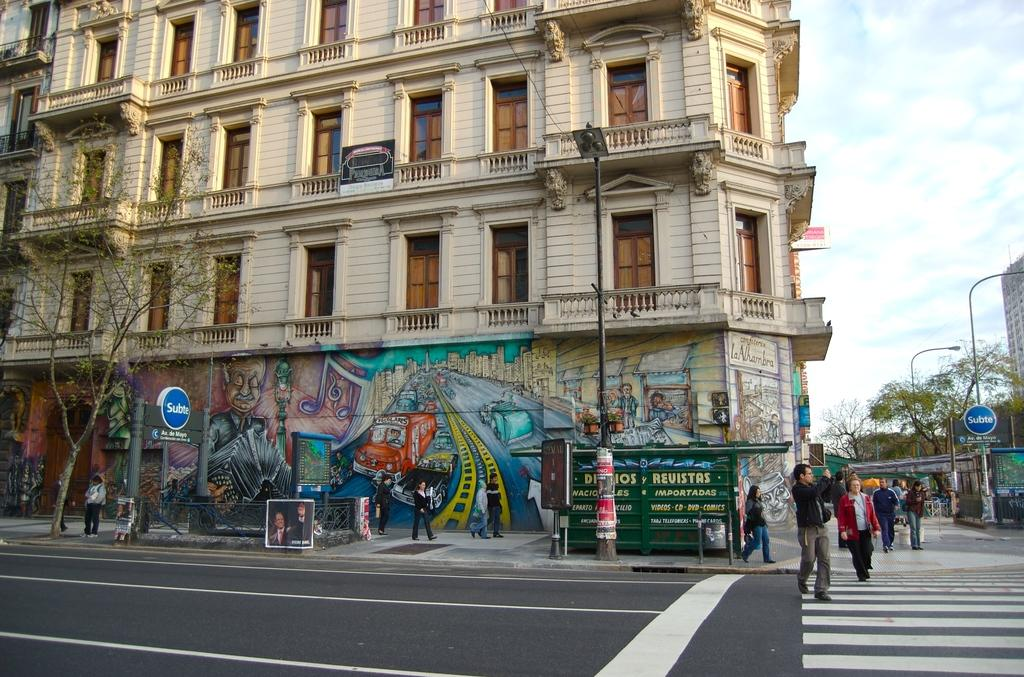What is the main structure in the image? There is a building in the image. Are there any people in the image? Yes, there are persons beside the building. What type of natural elements can be seen in the image? There are trees in the image. Can you describe the other building in the image? There is another building in the right corner of the image. How many girls are sitting on the chin of the woman in the image? There is no woman or girl present in the image. 